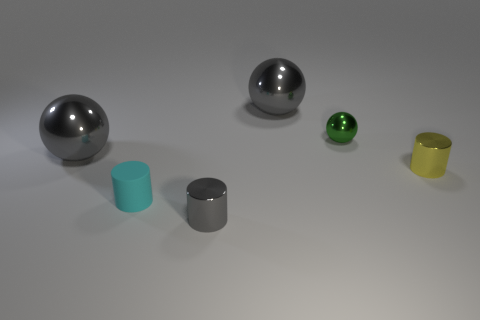Are there any other things that are the same color as the small matte object?
Offer a terse response. No. There is a metallic object that is left of the rubber object; what is its shape?
Give a very brief answer. Sphere. What shape is the gray thing that is both on the right side of the tiny cyan rubber thing and behind the cyan object?
Your answer should be very brief. Sphere. What number of purple things are either metal cylinders or large rubber cylinders?
Offer a very short reply. 0. Is the color of the large ball behind the green object the same as the tiny matte cylinder?
Offer a very short reply. No. There is a gray metallic ball that is in front of the gray thing that is on the right side of the small gray shiny cylinder; what size is it?
Keep it short and to the point. Large. What material is the cyan object that is the same size as the yellow object?
Your answer should be very brief. Rubber. What number of other objects are there of the same size as the green metallic thing?
Give a very brief answer. 3. How many cylinders are either tiny yellow shiny objects or metal objects?
Offer a very short reply. 2. Is there anything else that is made of the same material as the green thing?
Provide a succinct answer. Yes. 